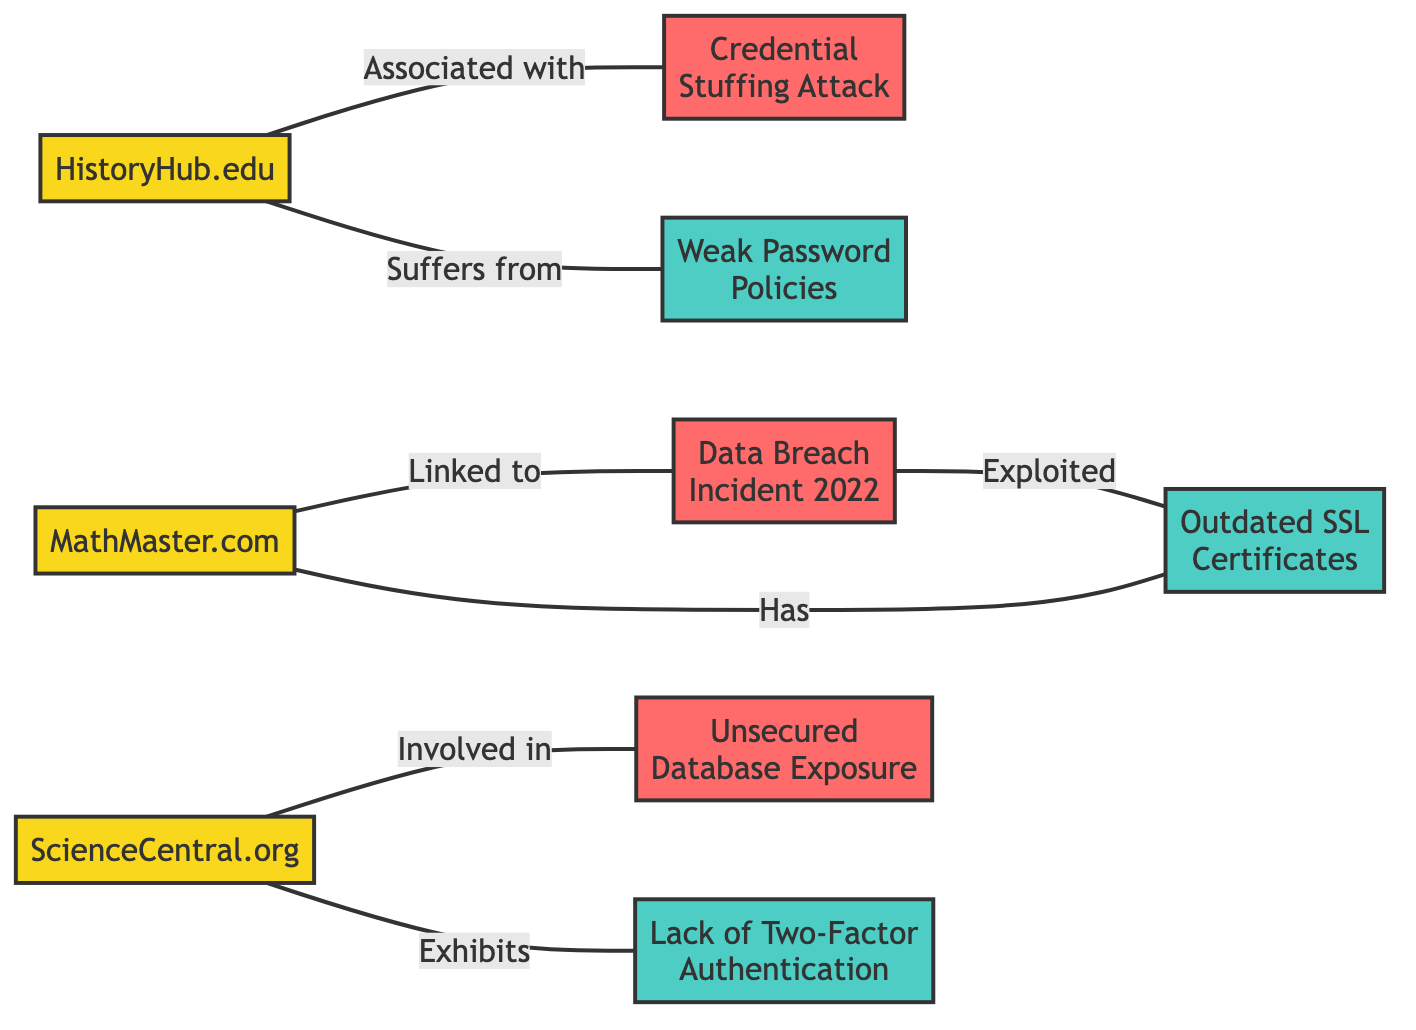What educational website is linked to the Data Breach Incident 2022? The diagram shows that MathMaster.com is linked to the Data Breach Incident 2022. This is indicated by the edge connecting the node MathMaster.com to the node labeled Data Breach Incident 2022 with the label "Linked to."
Answer: MathMaster.com How many educational websites are represented in the graph? The graph contains three educational websites: MathMaster.com, HistoryHub.edu, and ScienceCentral.org. Counting the nodes in the "nodes" section, we see three labeled as educational websites.
Answer: 3 Which security vulnerability is associated with HistoryHub.edu? The diagram indicates that HistoryHub.edu suffers from Weak Password Policies, evident from the edge connecting HistoryHub.edu to the node labeled Weak Password Policies with the label "Suffers from."
Answer: Weak Password Policies Which data breach is involved with ScienceCentral.org? The graph indicates that ScienceCentral.org is involved in the data breach labeled Unsecured Database Exposure. This is shown by the edge linking ScienceCentral.org to Unsecured Database Exposure with the label "Involved in."
Answer: Unsecured Database Exposure Which security vulnerability is exploited in the Data Breach Incident 2022? According to the diagram, the Data Breach Incident 2022 exploits Outdated SSL Certificates. This is shown by the edge connecting Data Breach Incident 2022 to the node labeled Outdated SSL Certificates with the label "Exploited."
Answer: Outdated SSL Certificates How many data breaches are associated with educational websites in total? There are three data breaches mentioned in the diagram that are associated with educational websites: Data Breach Incident 2022, Credential Stuffing Attack, and Unsecured Database Exposure. By counting the respective edges leading from educational websites to these data breach nodes, we confirm three total breaches.
Answer: 3 What is the relationship between MathMaster.com and its security vulnerability? The relationship is that MathMaster.com has Outdated SSL Certificates. This is detailed by the edge that links MathMaster.com to the node labeled Outdated SSL Certificates with the label "Has."
Answer: Has How many edges connect educational websites to their corresponding vulnerabilities? There are three edges connecting educational websites to their corresponding vulnerabilities. Each website has one security vulnerability associated with it, as evidenced by the edges in the graph.
Answer: 3 Which data breach is associated with a credential stuffing attack? The diagram indicates that the Credential Stuffing Attack is associated with HistoryHub.edu. This is indicated by the edge from HistoryHub.edu to the node labeled Credential Stuffing Attack with the label "Associated with."
Answer: Credential Stuffing Attack 